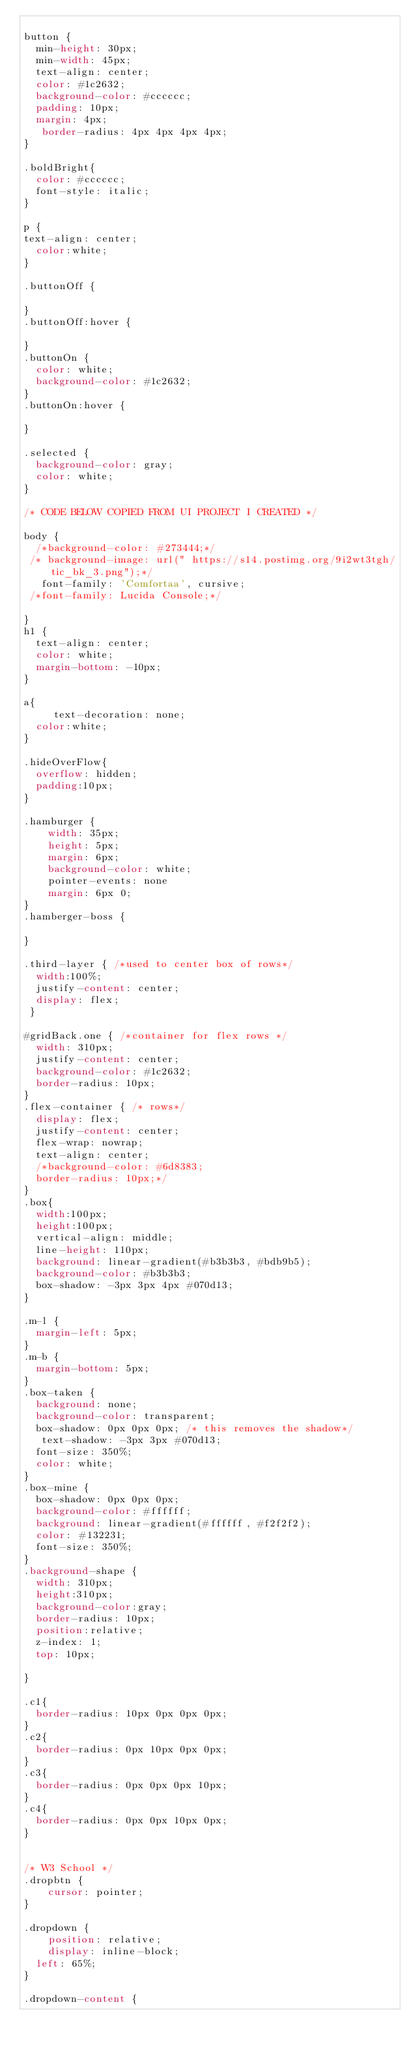<code> <loc_0><loc_0><loc_500><loc_500><_CSS_>
button {
  min-height: 30px;
  min-width: 45px; 
  text-align: center;
  color: #1c2632;
  background-color: #cccccc;
  padding: 10px;
  margin: 4px;
   border-radius: 4px 4px 4px 4px;
}

.boldBright{
  color: #cccccc;
  font-style: italic;
}

p { 
text-align: center;
  color:white;
}

.buttonOff {

}
.buttonOff:hover {
  
}
.buttonOn {
  color: white;
  background-color: #1c2632;
}
.buttonOn:hover {
  
}

.selected {
  background-color: gray;
  color: white;
}

/* CODE BELOW COPIED FROM UI PROJECT I CREATED */

body {
  /*background-color: #273444;*/
 /* background-image: url(" https://s14.postimg.org/9i2wt3tgh/tic_bk_3.png");*/
   font-family: 'Comfortaa', cursive;
 /*font-family: Lucida Console;*/

}
h1 {
  text-align: center;
  color: white;
  margin-bottom: -10px;
}

a{
     text-decoration: none;
  color:white;
}

.hideOverFlow{
  overflow: hidden;
  padding:10px;
}

.hamburger {
    width: 35px;
    height: 5px;
    margin: 6px;
    background-color: white;
    pointer-events: none
    margin: 6px 0;
}
.hamberger-boss {

}

.third-layer { /*used to center box of rows*/
  width:100%;
  justify-content: center;
  display: flex;
 }

#gridBack.one { /*container for flex rows */
  width: 310px;
  justify-content: center;
  background-color: #1c2632;
  border-radius: 10px;
}
.flex-container { /* rows*/
  display: flex;
  justify-content: center;
  flex-wrap: nowrap;
  text-align: center;
  /*background-color: #6d8383;
  border-radius: 10px;*/
}
.box{
  width:100px;
  height:100px;
  vertical-align: middle;
  line-height: 110px;
  background: linear-gradient(#b3b3b3, #bdb9b5);
  background-color: #b3b3b3;
  box-shadow: -3px 3px 4px #070d13;
}

.m-l {
  margin-left: 5px;
}
.m-b {
  margin-bottom: 5px;
}
.box-taken {
  background: none;
  background-color: transparent;
  box-shadow: 0px 0px 0px; /* this removes the shadow*/
   text-shadow: -3px 3px #070d13;
  font-size: 350%;
  color: white;
}
.box-mine {
  box-shadow: 0px 0px 0px;
  background-color: #ffffff;
  background: linear-gradient(#ffffff, #f2f2f2);
  color: #132231;
  font-size: 350%;
}
.background-shape {
  width: 310px;
  height:310px;
  background-color:gray;
  border-radius: 10px;
  position:relative;
  z-index: 1;
  top: 10px;
  
}

.c1{
  border-radius: 10px 0px 0px 0px;
}
.c2{
  border-radius: 0px 10px 0px 0px;
}
.c3{
  border-radius: 0px 0px 0px 10px;
}
.c4{
  border-radius: 0px 0px 10px 0px;
}


/* W3 School */
.dropbtn {
    cursor: pointer;
}

.dropdown {
    position: relative;
    display: inline-block;
  left: 65%;
}

.dropdown-content {</code> 